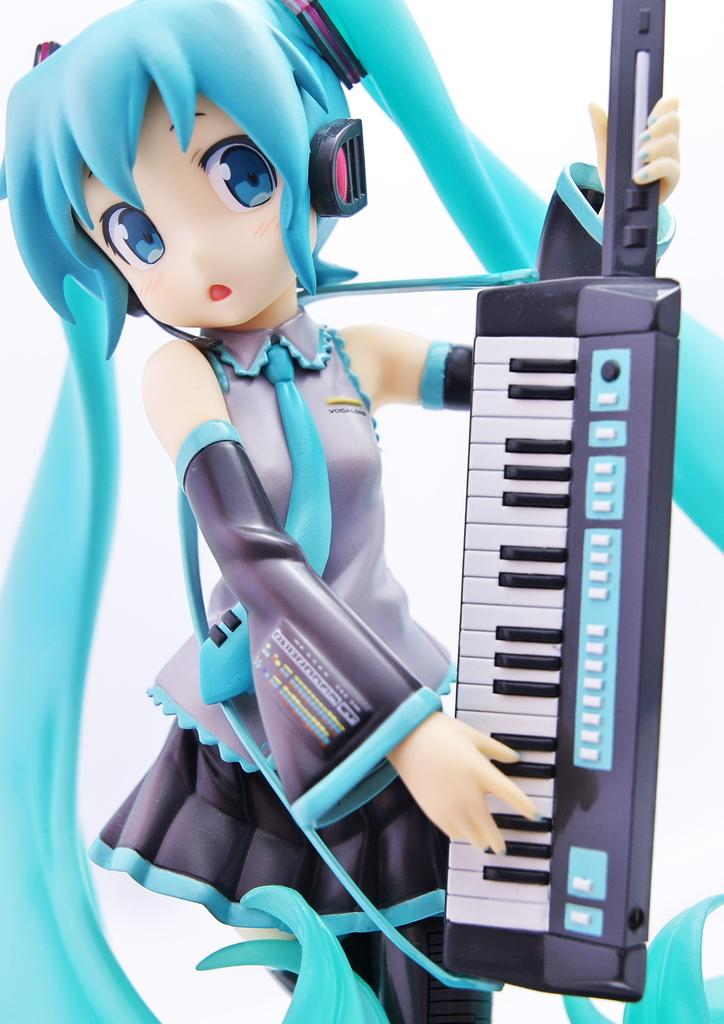Who is the main subject in the image? There is a girl in the image. What is the girl holding in the image? The girl is holding a keyboard. What color is the background of the image? The background of the image is white. Can you describe the editing style of the image? The image appears to be an edited photo. What type of setting might the image be in? The setting of the image is likely a house. What type of bells can be heard ringing in the image? There are no bells present in the image, and therefore no sound can be heard. What direction is the railway located in the image? There is no railway present in the image. 